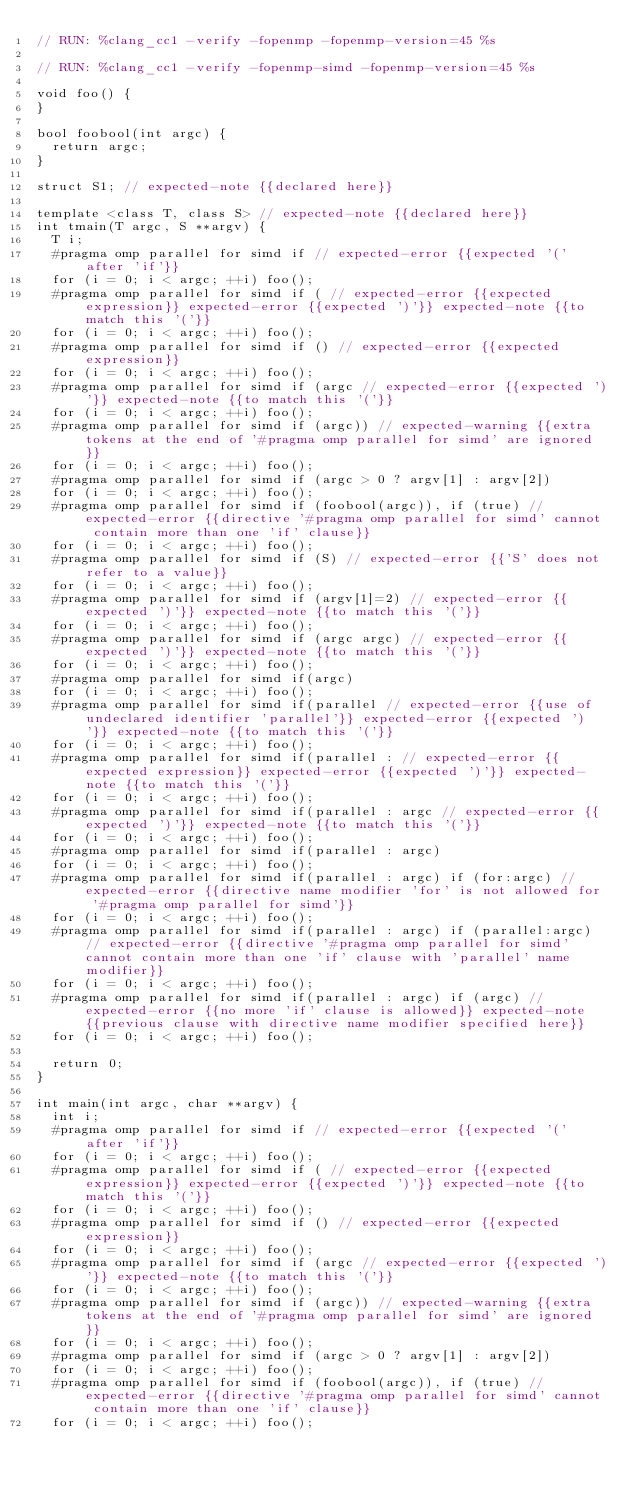Convert code to text. <code><loc_0><loc_0><loc_500><loc_500><_C++_>// RUN: %clang_cc1 -verify -fopenmp -fopenmp-version=45 %s

// RUN: %clang_cc1 -verify -fopenmp-simd -fopenmp-version=45 %s

void foo() {
}

bool foobool(int argc) {
  return argc;
}

struct S1; // expected-note {{declared here}}

template <class T, class S> // expected-note {{declared here}}
int tmain(T argc, S **argv) {
  T i;
  #pragma omp parallel for simd if // expected-error {{expected '(' after 'if'}}
  for (i = 0; i < argc; ++i) foo();
  #pragma omp parallel for simd if ( // expected-error {{expected expression}} expected-error {{expected ')'}} expected-note {{to match this '('}}
  for (i = 0; i < argc; ++i) foo();
  #pragma omp parallel for simd if () // expected-error {{expected expression}}
  for (i = 0; i < argc; ++i) foo();
  #pragma omp parallel for simd if (argc // expected-error {{expected ')'}} expected-note {{to match this '('}}
  for (i = 0; i < argc; ++i) foo();
  #pragma omp parallel for simd if (argc)) // expected-warning {{extra tokens at the end of '#pragma omp parallel for simd' are ignored}}
  for (i = 0; i < argc; ++i) foo();
  #pragma omp parallel for simd if (argc > 0 ? argv[1] : argv[2])
  for (i = 0; i < argc; ++i) foo();
  #pragma omp parallel for simd if (foobool(argc)), if (true) // expected-error {{directive '#pragma omp parallel for simd' cannot contain more than one 'if' clause}}
  for (i = 0; i < argc; ++i) foo();
  #pragma omp parallel for simd if (S) // expected-error {{'S' does not refer to a value}}
  for (i = 0; i < argc; ++i) foo();
  #pragma omp parallel for simd if (argv[1]=2) // expected-error {{expected ')'}} expected-note {{to match this '('}}
  for (i = 0; i < argc; ++i) foo();
  #pragma omp parallel for simd if (argc argc) // expected-error {{expected ')'}} expected-note {{to match this '('}}
  for (i = 0; i < argc; ++i) foo();
  #pragma omp parallel for simd if(argc)
  for (i = 0; i < argc; ++i) foo();
  #pragma omp parallel for simd if(parallel // expected-error {{use of undeclared identifier 'parallel'}} expected-error {{expected ')'}} expected-note {{to match this '('}}
  for (i = 0; i < argc; ++i) foo();
  #pragma omp parallel for simd if(parallel : // expected-error {{expected expression}} expected-error {{expected ')'}} expected-note {{to match this '('}}
  for (i = 0; i < argc; ++i) foo();
  #pragma omp parallel for simd if(parallel : argc // expected-error {{expected ')'}} expected-note {{to match this '('}}
  for (i = 0; i < argc; ++i) foo();
  #pragma omp parallel for simd if(parallel : argc)
  for (i = 0; i < argc; ++i) foo();
  #pragma omp parallel for simd if(parallel : argc) if (for:argc) // expected-error {{directive name modifier 'for' is not allowed for '#pragma omp parallel for simd'}}
  for (i = 0; i < argc; ++i) foo();
  #pragma omp parallel for simd if(parallel : argc) if (parallel:argc) // expected-error {{directive '#pragma omp parallel for simd' cannot contain more than one 'if' clause with 'parallel' name modifier}}
  for (i = 0; i < argc; ++i) foo();
  #pragma omp parallel for simd if(parallel : argc) if (argc) // expected-error {{no more 'if' clause is allowed}} expected-note {{previous clause with directive name modifier specified here}}
  for (i = 0; i < argc; ++i) foo();

  return 0;
}

int main(int argc, char **argv) {
  int i;
  #pragma omp parallel for simd if // expected-error {{expected '(' after 'if'}}
  for (i = 0; i < argc; ++i) foo();
  #pragma omp parallel for simd if ( // expected-error {{expected expression}} expected-error {{expected ')'}} expected-note {{to match this '('}}
  for (i = 0; i < argc; ++i) foo();
  #pragma omp parallel for simd if () // expected-error {{expected expression}}
  for (i = 0; i < argc; ++i) foo();
  #pragma omp parallel for simd if (argc // expected-error {{expected ')'}} expected-note {{to match this '('}}
  for (i = 0; i < argc; ++i) foo();
  #pragma omp parallel for simd if (argc)) // expected-warning {{extra tokens at the end of '#pragma omp parallel for simd' are ignored}}
  for (i = 0; i < argc; ++i) foo();
  #pragma omp parallel for simd if (argc > 0 ? argv[1] : argv[2])
  for (i = 0; i < argc; ++i) foo();
  #pragma omp parallel for simd if (foobool(argc)), if (true) // expected-error {{directive '#pragma omp parallel for simd' cannot contain more than one 'if' clause}}
  for (i = 0; i < argc; ++i) foo();</code> 